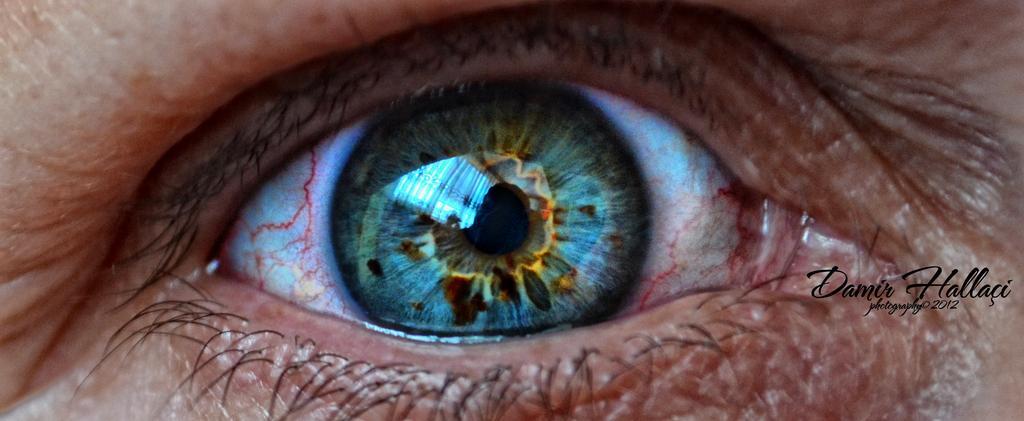How would you summarize this image in a sentence or two? In this image we can see an eye of a person and some text on it. 